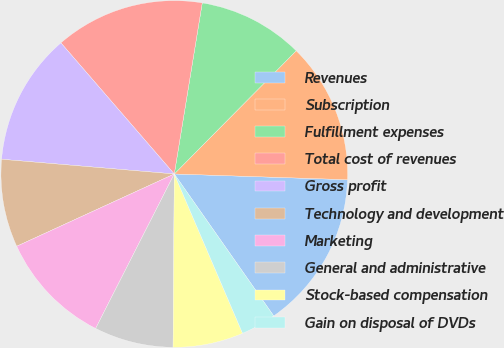Convert chart. <chart><loc_0><loc_0><loc_500><loc_500><pie_chart><fcel>Revenues<fcel>Subscription<fcel>Fulfillment expenses<fcel>Total cost of revenues<fcel>Gross profit<fcel>Technology and development<fcel>Marketing<fcel>General and administrative<fcel>Stock-based compensation<fcel>Gain on disposal of DVDs<nl><fcel>14.75%<fcel>13.11%<fcel>9.84%<fcel>13.93%<fcel>12.3%<fcel>8.2%<fcel>10.66%<fcel>7.38%<fcel>6.56%<fcel>3.28%<nl></chart> 